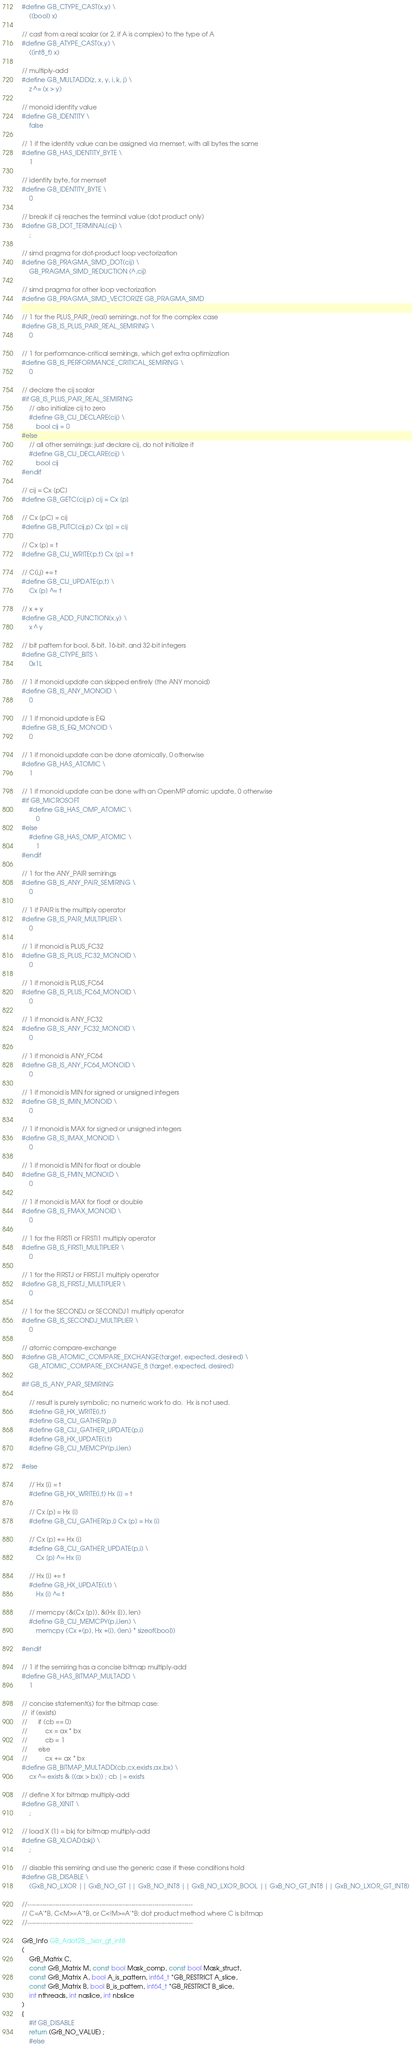Convert code to text. <code><loc_0><loc_0><loc_500><loc_500><_C_>#define GB_CTYPE_CAST(x,y) \
    ((bool) x)

// cast from a real scalar (or 2, if A is complex) to the type of A
#define GB_ATYPE_CAST(x,y) \
    ((int8_t) x)

// multiply-add
#define GB_MULTADD(z, x, y, i, k, j) \
    z ^= (x > y)

// monoid identity value
#define GB_IDENTITY \
    false

// 1 if the identity value can be assigned via memset, with all bytes the same
#define GB_HAS_IDENTITY_BYTE \
    1

// identity byte, for memset
#define GB_IDENTITY_BYTE \
    0

// break if cij reaches the terminal value (dot product only)
#define GB_DOT_TERMINAL(cij) \
    ;

// simd pragma for dot-product loop vectorization
#define GB_PRAGMA_SIMD_DOT(cij) \
    GB_PRAGMA_SIMD_REDUCTION (^,cij)

// simd pragma for other loop vectorization
#define GB_PRAGMA_SIMD_VECTORIZE GB_PRAGMA_SIMD

// 1 for the PLUS_PAIR_(real) semirings, not for the complex case
#define GB_IS_PLUS_PAIR_REAL_SEMIRING \
    0

// 1 for performance-critical semirings, which get extra optimization
#define GB_IS_PERFORMANCE_CRITICAL_SEMIRING \
    0

// declare the cij scalar
#if GB_IS_PLUS_PAIR_REAL_SEMIRING
    // also initialize cij to zero
    #define GB_CIJ_DECLARE(cij) \
        bool cij = 0
#else
    // all other semirings: just declare cij, do not initialize it
    #define GB_CIJ_DECLARE(cij) \
        bool cij
#endif

// cij = Cx [pC]
#define GB_GETC(cij,p) cij = Cx [p]

// Cx [pC] = cij
#define GB_PUTC(cij,p) Cx [p] = cij

// Cx [p] = t
#define GB_CIJ_WRITE(p,t) Cx [p] = t

// C(i,j) += t
#define GB_CIJ_UPDATE(p,t) \
    Cx [p] ^= t

// x + y
#define GB_ADD_FUNCTION(x,y) \
    x ^ y

// bit pattern for bool, 8-bit, 16-bit, and 32-bit integers
#define GB_CTYPE_BITS \
    0x1L

// 1 if monoid update can skipped entirely (the ANY monoid)
#define GB_IS_ANY_MONOID \
    0

// 1 if monoid update is EQ
#define GB_IS_EQ_MONOID \
    0

// 1 if monoid update can be done atomically, 0 otherwise
#define GB_HAS_ATOMIC \
    1

// 1 if monoid update can be done with an OpenMP atomic update, 0 otherwise
#if GB_MICROSOFT
    #define GB_HAS_OMP_ATOMIC \
        0
#else
    #define GB_HAS_OMP_ATOMIC \
        1
#endif

// 1 for the ANY_PAIR semirings
#define GB_IS_ANY_PAIR_SEMIRING \
    0

// 1 if PAIR is the multiply operator 
#define GB_IS_PAIR_MULTIPLIER \
    0

// 1 if monoid is PLUS_FC32
#define GB_IS_PLUS_FC32_MONOID \
    0

// 1 if monoid is PLUS_FC64
#define GB_IS_PLUS_FC64_MONOID \
    0

// 1 if monoid is ANY_FC32
#define GB_IS_ANY_FC32_MONOID \
    0

// 1 if monoid is ANY_FC64
#define GB_IS_ANY_FC64_MONOID \
    0

// 1 if monoid is MIN for signed or unsigned integers
#define GB_IS_IMIN_MONOID \
    0

// 1 if monoid is MAX for signed or unsigned integers
#define GB_IS_IMAX_MONOID \
    0

// 1 if monoid is MIN for float or double
#define GB_IS_FMIN_MONOID \
    0

// 1 if monoid is MAX for float or double
#define GB_IS_FMAX_MONOID \
    0

// 1 for the FIRSTI or FIRSTI1 multiply operator
#define GB_IS_FIRSTI_MULTIPLIER \
    0

// 1 for the FIRSTJ or FIRSTJ1 multiply operator
#define GB_IS_FIRSTJ_MULTIPLIER \
    0

// 1 for the SECONDJ or SECONDJ1 multiply operator
#define GB_IS_SECONDJ_MULTIPLIER \
    0

// atomic compare-exchange
#define GB_ATOMIC_COMPARE_EXCHANGE(target, expected, desired) \
    GB_ATOMIC_COMPARE_EXCHANGE_8 (target, expected, desired)

#if GB_IS_ANY_PAIR_SEMIRING

    // result is purely symbolic; no numeric work to do.  Hx is not used.
    #define GB_HX_WRITE(i,t)
    #define GB_CIJ_GATHER(p,i)
    #define GB_CIJ_GATHER_UPDATE(p,i)
    #define GB_HX_UPDATE(i,t)
    #define GB_CIJ_MEMCPY(p,i,len)

#else

    // Hx [i] = t
    #define GB_HX_WRITE(i,t) Hx [i] = t

    // Cx [p] = Hx [i]
    #define GB_CIJ_GATHER(p,i) Cx [p] = Hx [i]

    // Cx [p] += Hx [i]
    #define GB_CIJ_GATHER_UPDATE(p,i) \
        Cx [p] ^= Hx [i]

    // Hx [i] += t
    #define GB_HX_UPDATE(i,t) \
        Hx [i] ^= t

    // memcpy (&(Cx [p]), &(Hx [i]), len)
    #define GB_CIJ_MEMCPY(p,i,len) \
        memcpy (Cx +(p), Hx +(i), (len) * sizeof(bool))

#endif

// 1 if the semiring has a concise bitmap multiply-add
#define GB_HAS_BITMAP_MULTADD \
    1

// concise statement(s) for the bitmap case:
//  if (exists)
//      if (cb == 0)
//          cx = ax * bx
//          cb = 1
//      else
//          cx += ax * bx
#define GB_BITMAP_MULTADD(cb,cx,exists,ax,bx) \
    cx ^= exists & ((ax > bx)) ; cb |= exists

// define X for bitmap multiply-add
#define GB_XINIT \
    ;

// load X [1] = bkj for bitmap multiply-add
#define GB_XLOAD(bkj) \
    ;

// disable this semiring and use the generic case if these conditions hold
#define GB_DISABLE \
    (GxB_NO_LXOR || GxB_NO_GT || GxB_NO_INT8 || GxB_NO_LXOR_BOOL || GxB_NO_GT_INT8 || GxB_NO_LXOR_GT_INT8)

//------------------------------------------------------------------------------
// C=A'*B, C<M>=A'*B, or C<!M>=A'*B: dot product method where C is bitmap
//------------------------------------------------------------------------------

GrB_Info GB_Adot2B__lxor_gt_int8
(
    GrB_Matrix C,
    const GrB_Matrix M, const bool Mask_comp, const bool Mask_struct,
    const GrB_Matrix A, bool A_is_pattern, int64_t *GB_RESTRICT A_slice,
    const GrB_Matrix B, bool B_is_pattern, int64_t *GB_RESTRICT B_slice,
    int nthreads, int naslice, int nbslice
)
{ 
    #if GB_DISABLE
    return (GrB_NO_VALUE) ;
    #else</code> 